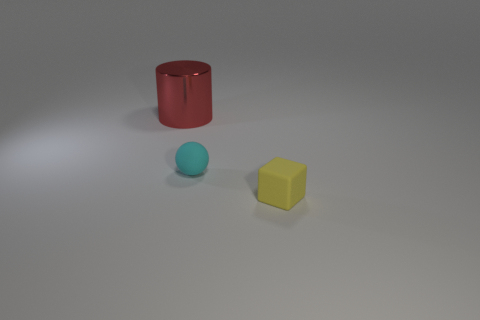Is there any other thing that has the same material as the large cylinder?
Offer a very short reply. No. How many other things are there of the same material as the cyan ball?
Offer a very short reply. 1. Does the block have the same size as the red metallic cylinder that is left of the tiny matte ball?
Your answer should be compact. No. Are there fewer tiny rubber blocks on the right side of the red shiny thing than small cyan objects that are to the left of the cyan rubber sphere?
Ensure brevity in your answer.  No. What is the size of the matte thing to the left of the yellow thing?
Your response must be concise. Small. Is the red metallic object the same size as the matte block?
Keep it short and to the point. No. What number of objects are both behind the cyan ball and in front of the cyan matte object?
Your answer should be compact. 0. How many gray objects are cubes or rubber balls?
Ensure brevity in your answer.  0. What number of matte things are tiny purple spheres or red objects?
Your answer should be compact. 0. Is there a big rubber cylinder?
Your response must be concise. No. 